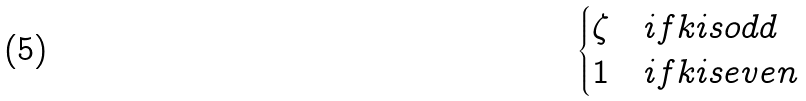Convert formula to latex. <formula><loc_0><loc_0><loc_500><loc_500>\begin{cases} \zeta & i f k i s o d d \\ 1 & i f k i s e v e n \\ \end{cases}</formula> 